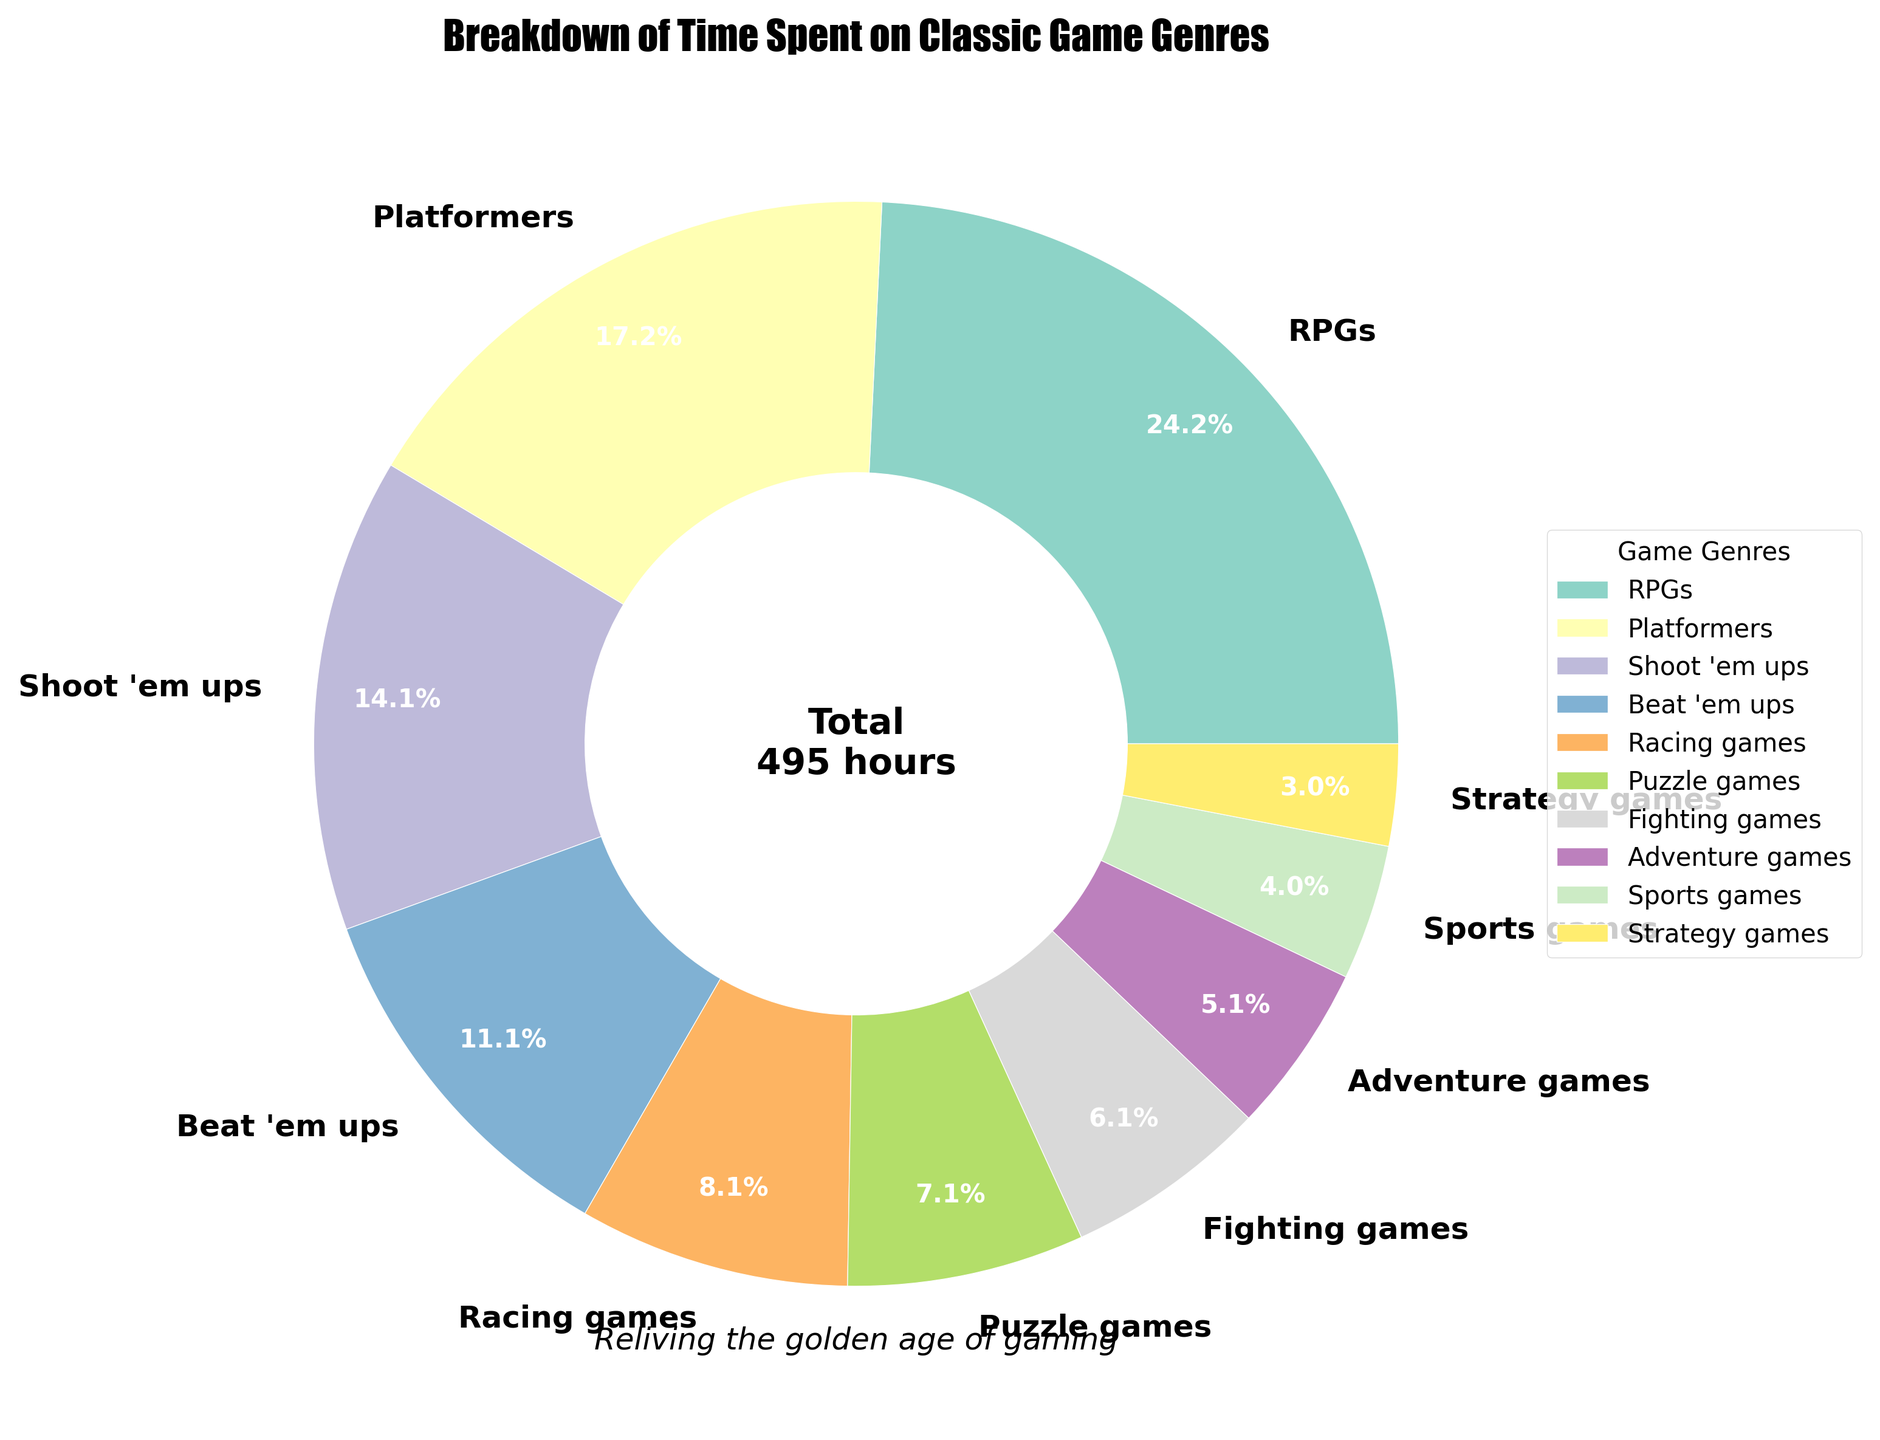Which genre has the highest percentage of total hours spent? The genre with the highest percentage can be identified by the largest wedge in the pie chart. Referring to the figure, RPGs have the largest wedge with 120 hours, representing the highest percentage.
Answer: RPGs What is the combined percentage of hours spent on Puzzle games and Fighting games? The chart displays each genre's percentage. Puzzle games have 35 hours (total 350 hours) and Fighting games have 30 hours. Their percentages are (35/350) * 100 ≈ 10% and (30/350) * 100 ≈ 8.6% respectively, hence combined ≈ 10% + 8.6% ≈ 18.6%.
Answer: 18.6% Which genres have the closest percentage of time spent? To find the closest percentages, compare the size of the wedges visually or look at the values: Beat 'em ups 55 hours, Racing games 40 hours. Their percentages are (55/350)*100 ≈ 15.7% and (40/350)*100 ≈ 11.4%, differences of ≈ 4.3%. Checking others, Adventure games and Sports games are at ≈ similar levels of 7.1% and 5.7%.
Answer: Adventure games and Sports games How many more hours are spent on RPGs compared to Strategy games? From the data, RPGs have 120 hours and Strategy games have 15 hours. Subtracting these gives 120 - 15 = 105 hours more.
Answer: 105 hours What is the percentage difference between Platformers and Shoot 'em ups? Platformers have 85 hours and Shoot 'em ups have 70 hours. Their percentages are (85/350)*100 ≈ 24.3% and (70/350)*100 ≈ 20%. Difference is 24.3% - 20% = 4.3%.
Answer: 4.3% What percentage of time is spent on non-action genres (Puzzle and Strategy games)? Puzzle games have 35 hours and Strategy games have 15 hours, totaling 35 + 15 = 50 hours. To find the percentage: (50/350) * 100 ≈ 14.3%.
Answer: 14.3% Which genre's wedge is a shade of orange? The pie chart colors are variable, but viewing the chart, we've attributed the pie edge color with the highest visual similarity to orange to potentially match Beat 'em ups visually, having 55 hours.
Answer: Beat 'em ups Out of the total time, how much more is spent on Beat 'em ups than Adventure games? Beat 'em ups have 55 hours and Adventure games have 25 hours. Subtracting these gives 55 - 25 = 30 hours more.
Answer: 30 hours Which genre uses the color green in their wedge? In pie charts, genres are distinguished by colors. Upon viewing, Racing games may use a greenish shade for visual distinction with 40 hours.
Answer: Racing games 